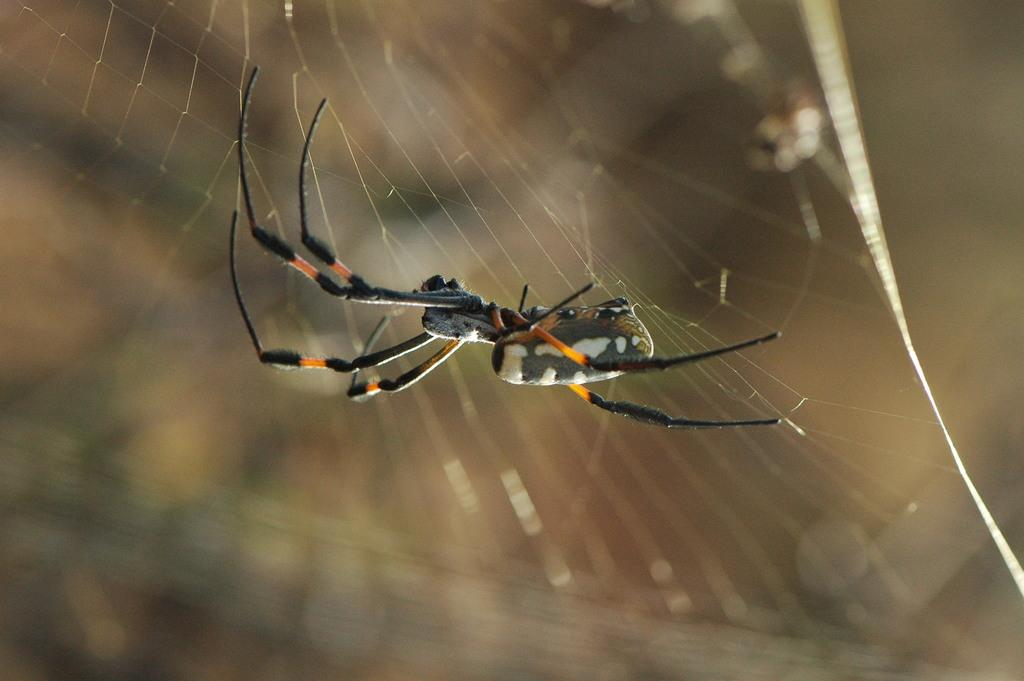What is the main subject of the image? The main subject of the image is a spider. What is associated with the spider in the image? There is a spider web in the image. What type of pancake is being served at the discovery event in the image? There is no discovery event or pancake present in the image; it features a spider and a spider web. How many toes can be seen on the spider in the image? Spiders do not have toes; they have eight legs, which are visible in the image. 